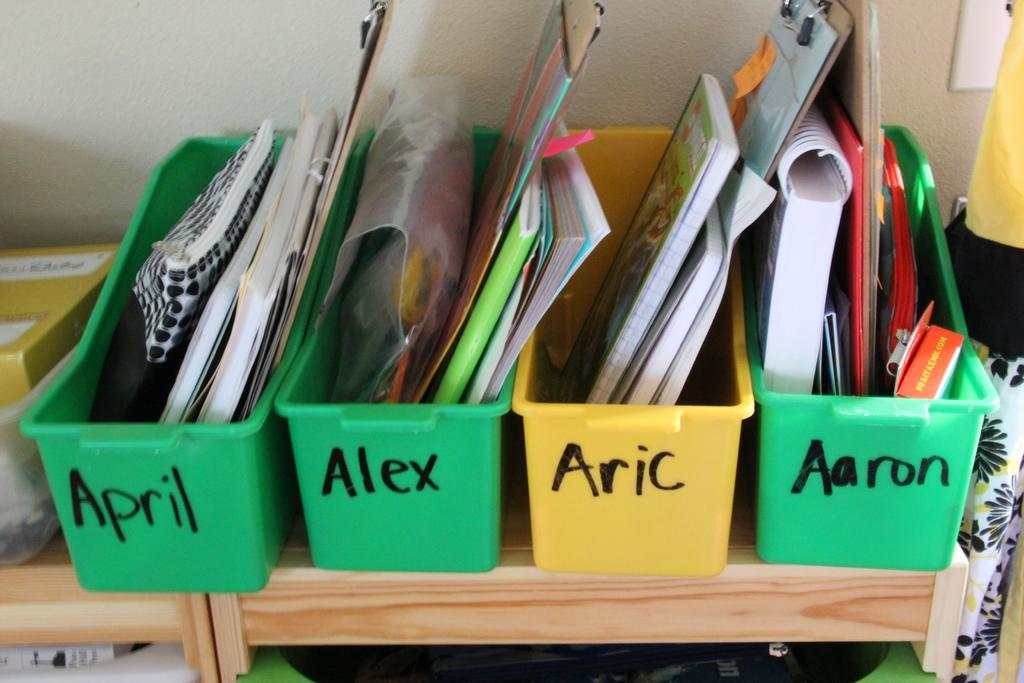<image>
Create a compact narrative representing the image presented. Four boxes of school supplies with the names, April,Alex, Aric, and Aaron. 